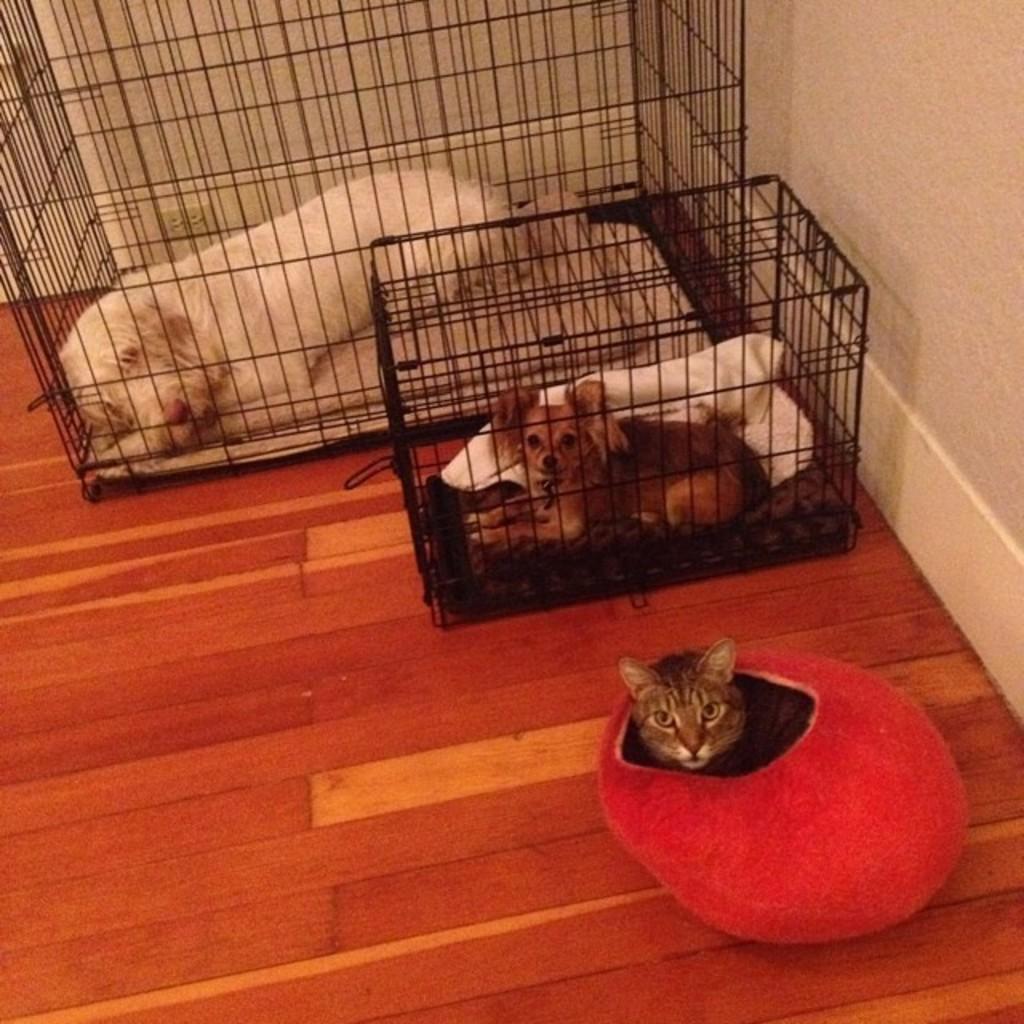Could you give a brief overview of what you see in this image? In this picture, we see a dog and a puppy are placed in the cages. Beside that, we see a cat is sitting in the red color box like. On the right side, we see a wall in white color. 